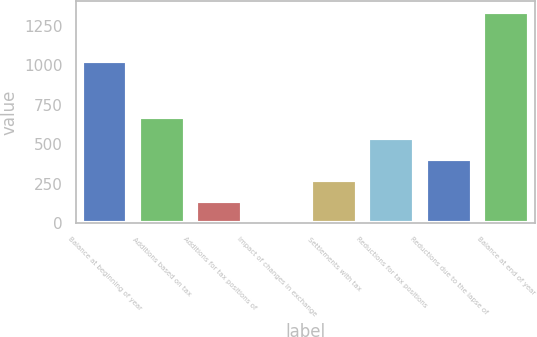Convert chart. <chart><loc_0><loc_0><loc_500><loc_500><bar_chart><fcel>Balance at beginning of year<fcel>Additions based on tax<fcel>Additions for tax positions of<fcel>Impact of changes in exchange<fcel>Settlements with tax<fcel>Reductions for tax positions<fcel>Reductions due to the lapse of<fcel>Balance at end of year<nl><fcel>1026<fcel>670.5<fcel>136.5<fcel>3<fcel>270<fcel>537<fcel>403.5<fcel>1338<nl></chart> 